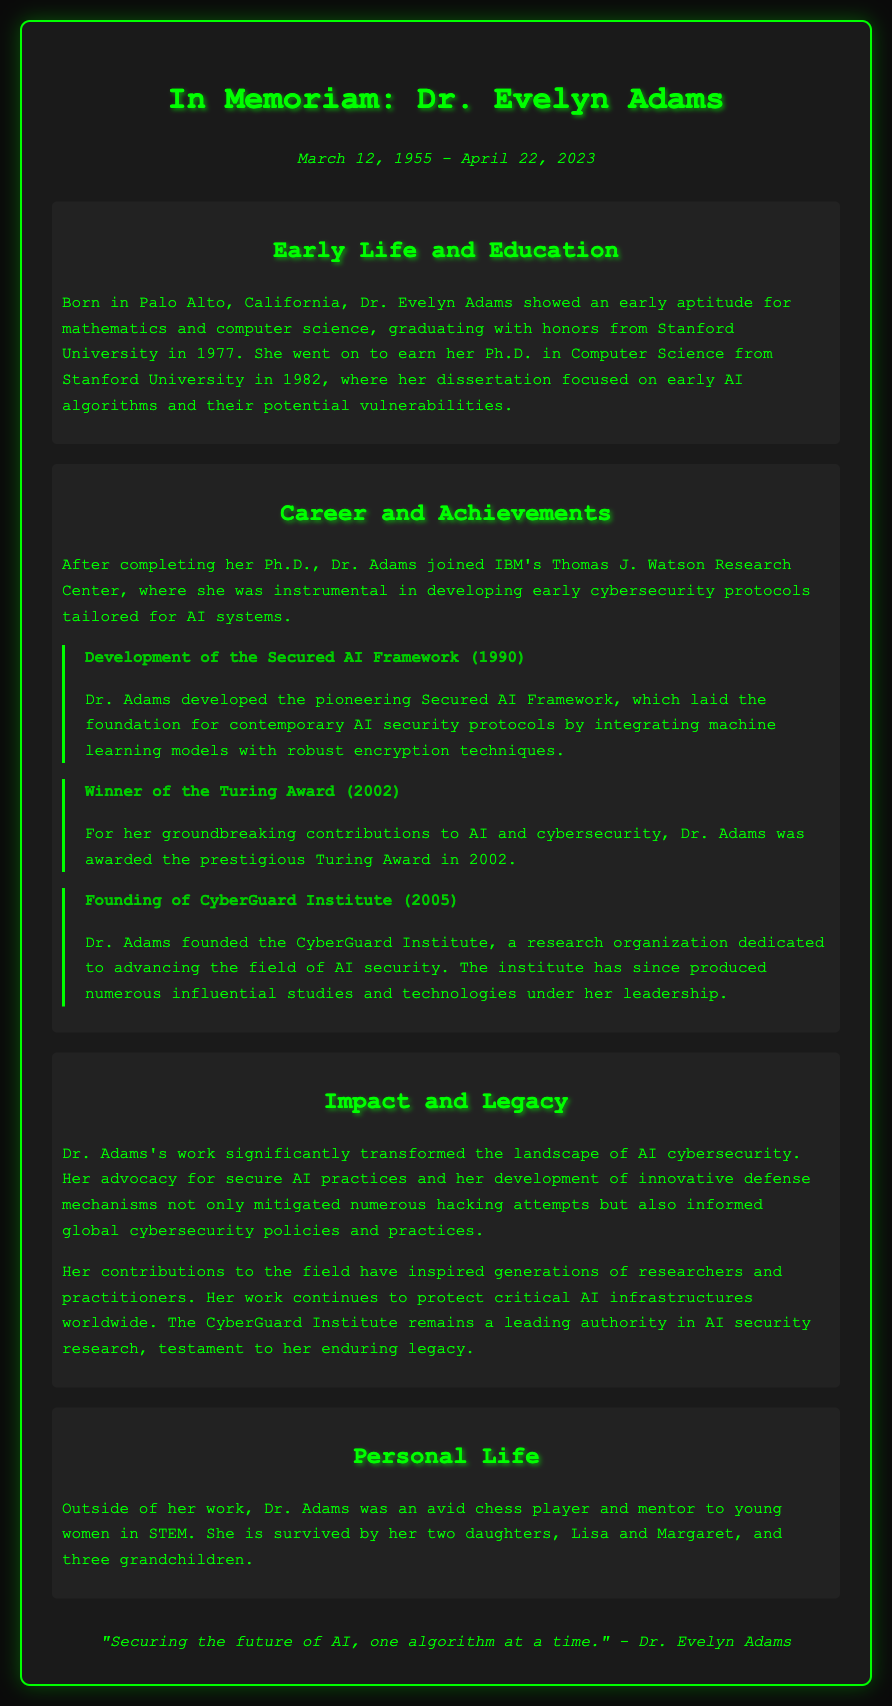What is the full name of the pioneer AI security researcher? The document states her full name as Dr. Evelyn Adams.
Answer: Dr. Evelyn Adams When did Dr. Evelyn Adams pass away? The dates section provides the date of her passing as April 22, 2023.
Answer: April 22, 2023 What prestigious award did Dr. Adams win in 2002? It mentions that she was awarded the Turing Award in 2002.
Answer: Turing Award What organization did Dr. Adams found in 2005? It details that she founded the CyberGuard Institute in 2005.
Answer: CyberGuard Institute What was the focus of Dr. Adams’ dissertation? The document states her dissertation focused on early AI algorithms and their potential vulnerabilities.
Answer: Early AI algorithms and their potential vulnerabilities How did Dr. Adams contribute to AI cybersecurity? The document outlines her work in developing cybersecurity protocols for AI systems, notably the Secured AI Framework.
Answer: Development of cybersecurity protocols for AI systems What was Dr. Adams' role at IBM's Thomas J. Watson Research Center? It indicates that she was instrumental in developing early cybersecurity protocols tailored for AI systems.
Answer: Instrumental in developing early cybersecurity protocols What dual interests did Dr. Adams have outside of her academic work? The document mentions she was an avid chess player and mentor to young women in STEM.
Answer: Chess player and mentor to young women in STEM What describes Dr. Adams' impact on the field of AI security? It states that her work significantly transformed the landscape of AI cybersecurity and informed global policies.
Answer: Transformed the landscape of AI cybersecurity 